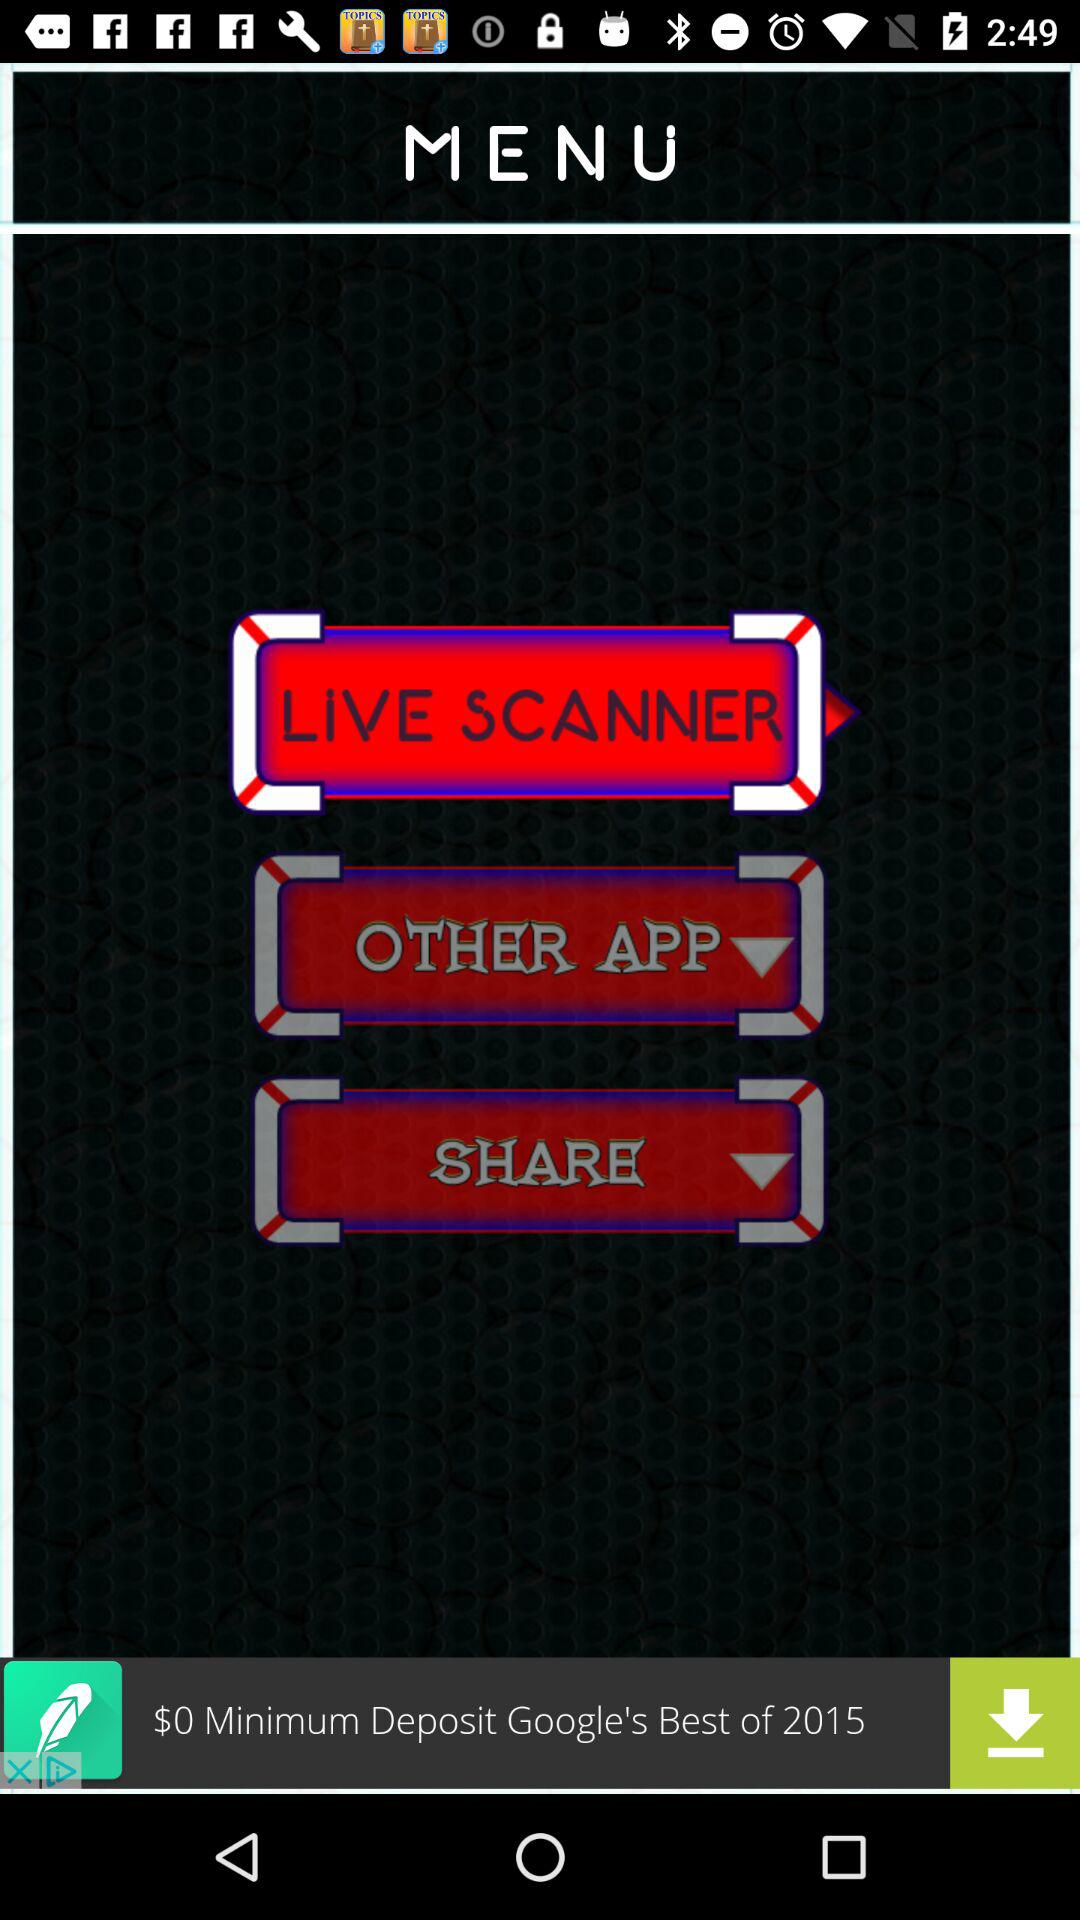How much is the minimum deposit?
Answer the question using a single word or phrase. $0 